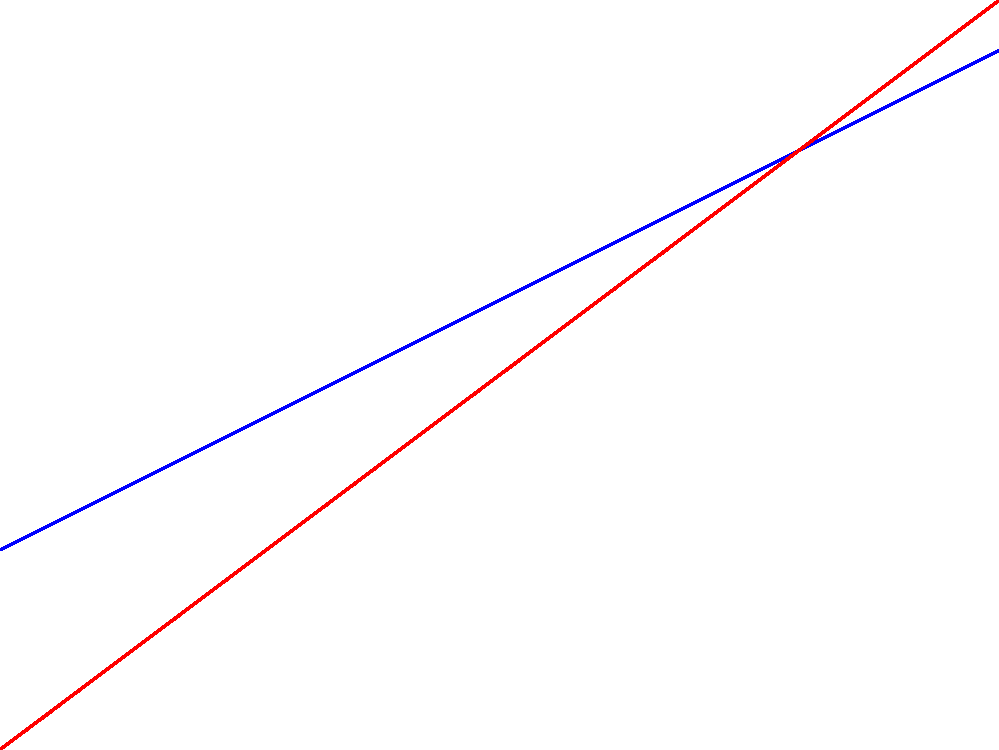Based on the graph showing the growth of diplomatic influence and family media presence over time, at what point do the two lines intersect, indicating equal levels of growth? To find the intersection point, we need to solve the equation where the two lines are equal:

1. Let $y_1 = 2 + 0.5x$ (Diplomatic Influence)
2. Let $y_2 = 1 + 0.75x$ (Family Media Presence)
3. At the intersection point: $y_1 = y_2$
4. Therefore: $2 + 0.5x = 1 + 0.75x$
5. Simplifying: $1 = 0.25x$
6. Solving for $x$: $x = 1 / 0.25 = 4$

The intersection occurs at $x = 4$ years.

To verify the $y$ coordinate:
$y = 2 + 0.5(4) = 4$ or $y = 1 + 0.75(4) = 4$

Thus, the intersection point is (4, 4).
Answer: 4 years 